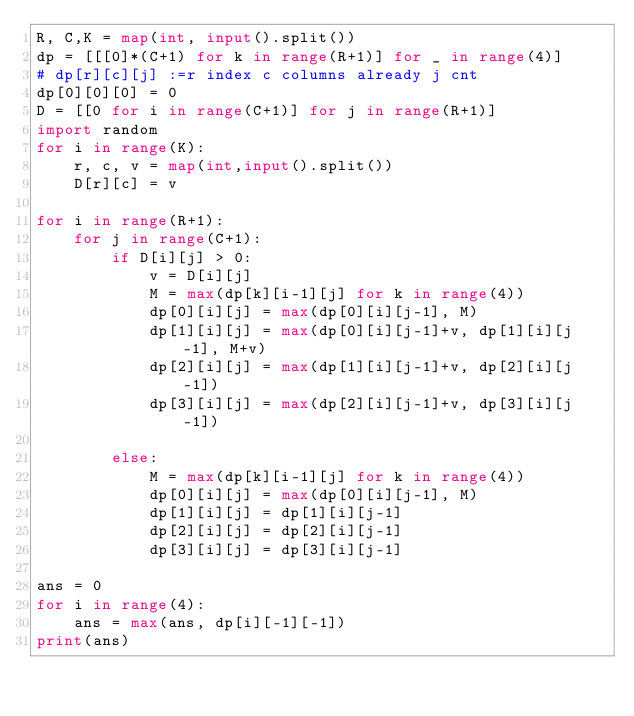Convert code to text. <code><loc_0><loc_0><loc_500><loc_500><_Python_>R, C,K = map(int, input().split())
dp = [[[0]*(C+1) for k in range(R+1)] for _ in range(4)]
# dp[r][c][j] :=r index c columns already j cnt
dp[0][0][0] = 0
D = [[0 for i in range(C+1)] for j in range(R+1)]
import random
for i in range(K):
    r, c, v = map(int,input().split())
    D[r][c] = v

for i in range(R+1):
    for j in range(C+1):
        if D[i][j] > 0:
            v = D[i][j]
            M = max(dp[k][i-1][j] for k in range(4))
            dp[0][i][j] = max(dp[0][i][j-1], M)
            dp[1][i][j] = max(dp[0][i][j-1]+v, dp[1][i][j-1], M+v)
            dp[2][i][j] = max(dp[1][i][j-1]+v, dp[2][i][j-1])
            dp[3][i][j] = max(dp[2][i][j-1]+v, dp[3][i][j-1])

        else:
            M = max(dp[k][i-1][j] for k in range(4))
            dp[0][i][j] = max(dp[0][i][j-1], M)
            dp[1][i][j] = dp[1][i][j-1]
            dp[2][i][j] = dp[2][i][j-1]
            dp[3][i][j] = dp[3][i][j-1]

ans = 0
for i in range(4):
    ans = max(ans, dp[i][-1][-1])
print(ans)
</code> 